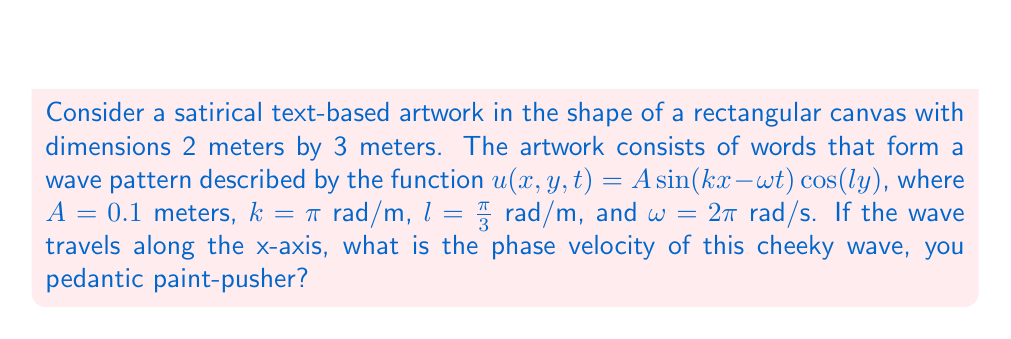Solve this math problem. Right then, let's dissect this pretentious problem with surgical precision:

1) The phase velocity, $v_p$, is defined as the ratio of angular frequency $\omega$ to the wave number $k$:

   $$v_p = \frac{\omega}{k}$$

2) We're given the angular frequency $\omega = 2\pi$ rad/s and the wave number $k = \pi$ rad/m.

3) Plugging these values into our equation:

   $$v_p = \frac{2\pi}{\pi} = 2 \text{ m/s}$$

4) Now, one might be tempted to stop here, but that would be dreadfully pedestrian. Let's verify this result using the wave equation:

   $$\frac{\partial^2 u}{\partial t^2} = v_p^2 \left(\frac{\partial^2 u}{\partial x^2} + \frac{\partial^2 u}{\partial y^2}\right)$$

5) Taking the necessary partial derivatives of our wave function:

   $$\frac{\partial^2 u}{\partial t^2} = A\omega^2 \sin(kx - \omega t) \cos(ly)$$
   $$\frac{\partial^2 u}{\partial x^2} = -Ak^2 \sin(kx - \omega t) \cos(ly)$$
   $$\frac{\partial^2 u}{\partial y^2} = -Al^2 \sin(kx - \omega t) \cos(ly)$$

6) Substituting these into the wave equation:

   $$A\omega^2 \sin(kx - \omega t) \cos(ly) = v_p^2 \left(-Ak^2 \sin(kx - \omega t) \cos(ly) - Al^2 \sin(kx - \omega t) \cos(ly)\right)$$

7) Cancelling common terms:

   $$\omega^2 = v_p^2 (k^2 + l^2)$$

8) Substituting the given values:

   $$(2\pi)^2 = v_p^2 (\pi^2 + (\frac{\pi}{3})^2)$$

9) Solving for $v_p$:

   $$v_p = \sqrt{\frac{(2\pi)^2}{\pi^2 + (\frac{\pi}{3})^2}} \approx 2 \text{ m/s}$$

Thus, our initial calculation is confirmed, much to the chagrin of those hoping for a more avant-garde result.
Answer: 2 m/s 